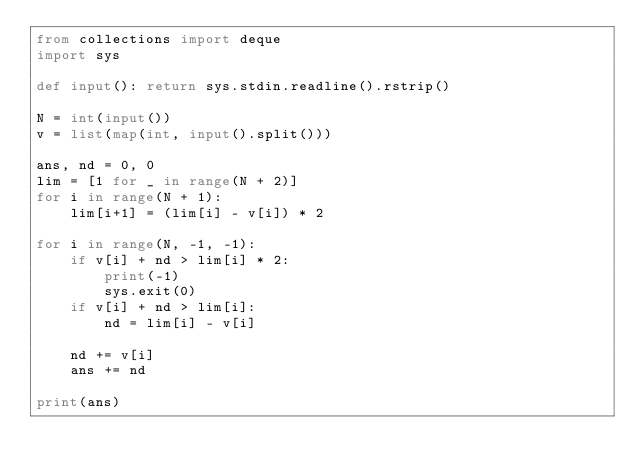<code> <loc_0><loc_0><loc_500><loc_500><_Python_>from collections import deque
import sys

def input(): return sys.stdin.readline().rstrip()

N = int(input())
v = list(map(int, input().split()))

ans, nd = 0, 0
lim = [1 for _ in range(N + 2)]
for i in range(N + 1):
    lim[i+1] = (lim[i] - v[i]) * 2

for i in range(N, -1, -1):
    if v[i] + nd > lim[i] * 2:
        print(-1)
        sys.exit(0)
    if v[i] + nd > lim[i]:
        nd = lim[i] - v[i]

    nd += v[i]
    ans += nd

print(ans)</code> 